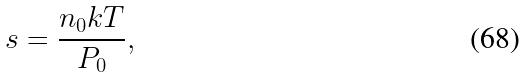<formula> <loc_0><loc_0><loc_500><loc_500>s = \frac { n _ { 0 } k T } { P _ { 0 } } ,</formula> 